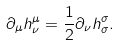Convert formula to latex. <formula><loc_0><loc_0><loc_500><loc_500>\partial _ { \mu } h ^ { \mu } _ { \nu } = \frac { 1 } { 2 } \partial _ { \nu } h ^ { \sigma } _ { \sigma } .</formula> 